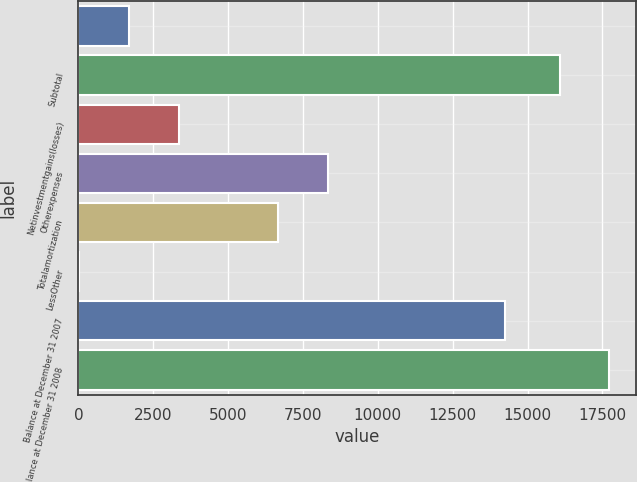Convert chart to OTSL. <chart><loc_0><loc_0><loc_500><loc_500><bar_chart><ecel><fcel>Subtotal<fcel>Netinvestmentgains(losses)<fcel>Otherexpenses<fcel>Totalamortization<fcel>LessOther<fcel>Balance at December 31 2007<fcel>Balance at December 31 2008<nl><fcel>1692.3<fcel>16071<fcel>3354.6<fcel>8341.5<fcel>6679.2<fcel>30<fcel>14260<fcel>17733.3<nl></chart> 